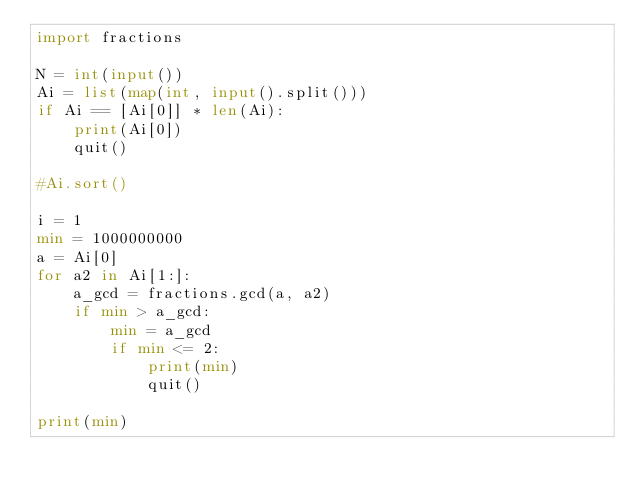<code> <loc_0><loc_0><loc_500><loc_500><_Python_>import fractions

N = int(input())
Ai = list(map(int, input().split()))
if Ai == [Ai[0]] * len(Ai):
    print(Ai[0])
    quit()

#Ai.sort()

i = 1
min = 1000000000
a = Ai[0]
for a2 in Ai[1:]:
    a_gcd = fractions.gcd(a, a2)
    if min > a_gcd:
        min = a_gcd
        if min <= 2:
            print(min)
            quit()

print(min)</code> 